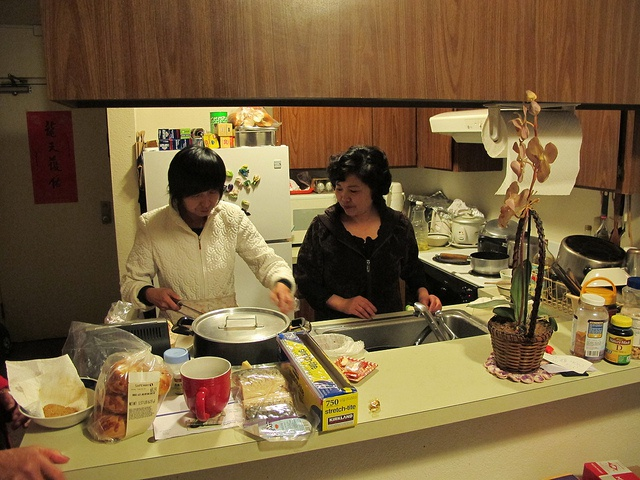Describe the objects in this image and their specific colors. I can see people in black, tan, and olive tones, people in black, maroon, and brown tones, potted plant in black, olive, maroon, and tan tones, refrigerator in black, khaki, and tan tones, and sink in black, darkgreen, tan, and gray tones in this image. 